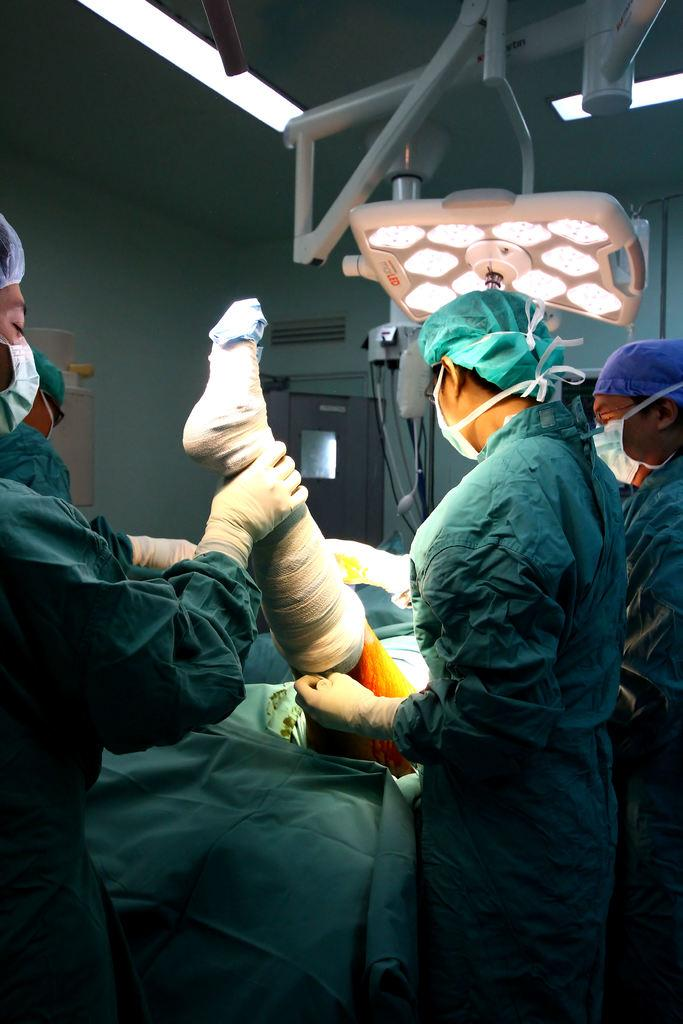How many people are present in the image? There are four persons standing in the image. What is the position of the fifth person in the image? There is a person on the bed. What can be seen in the image that provides illumination? There are lights visible in the image. What architectural feature is present in the image? There is a door in the image. What type of structure is visible in the image? There is a wall in the image. Can you see any cats or giraffes on the coast in the image? There are no cats, giraffes, or coast visible in the image. 